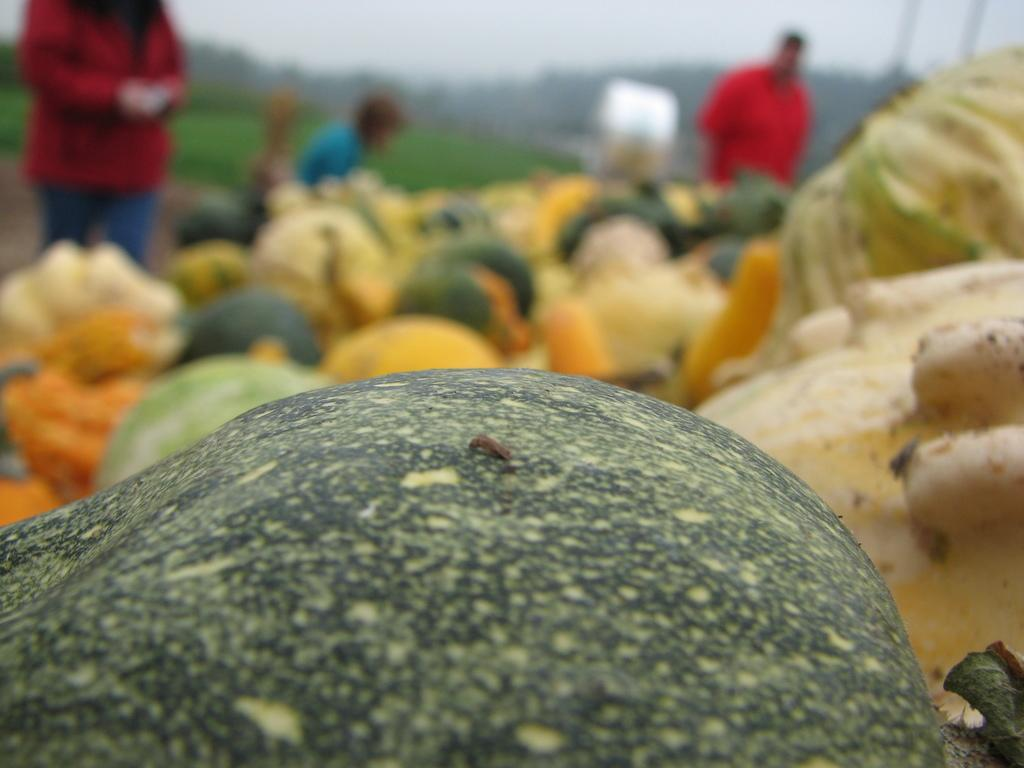What type of food can be seen in the image? There are fruits in the image. What else can be seen in the image besides the fruits? There are people standing in the backdrop of the image. How is the backdrop of the image depicted? The backdrop of the image is blurred. What is the title of the humor piece in the image? There is no humor piece or title present in the image; it features fruits and people in the backdrop. 